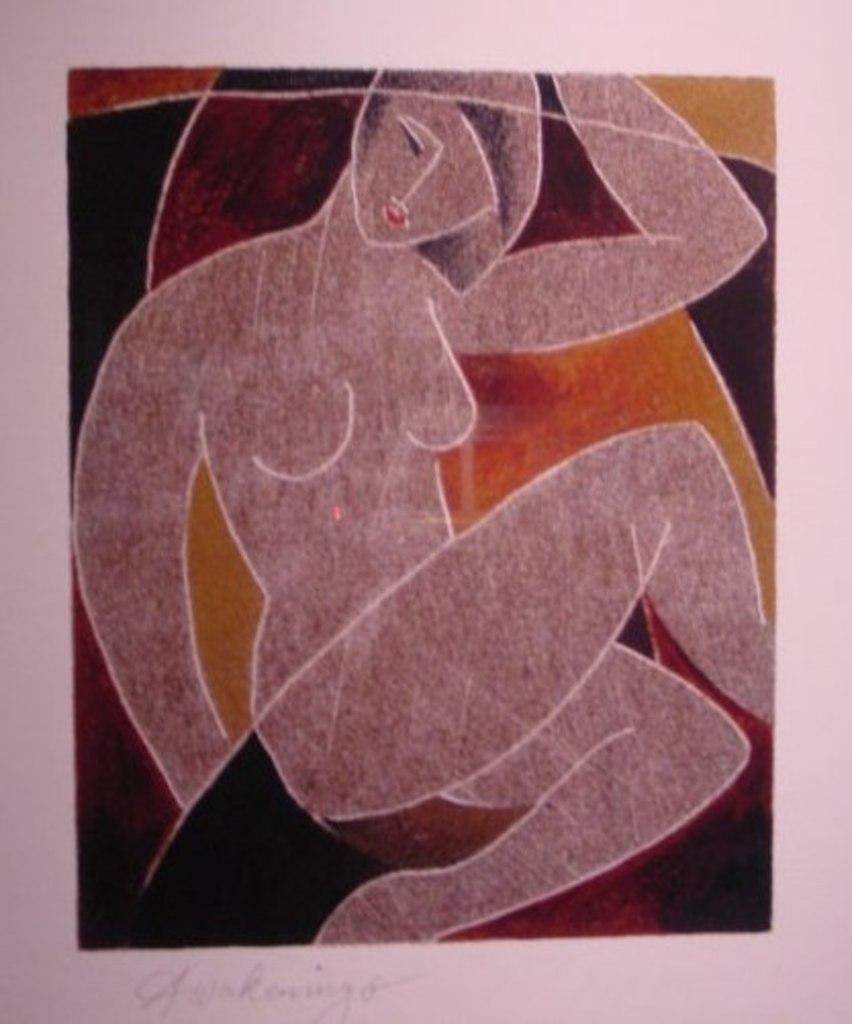Could you give a brief overview of what you see in this image? In this picture we can see a painting of a person sitting on an object. At the bottom we can see the text on the image. 